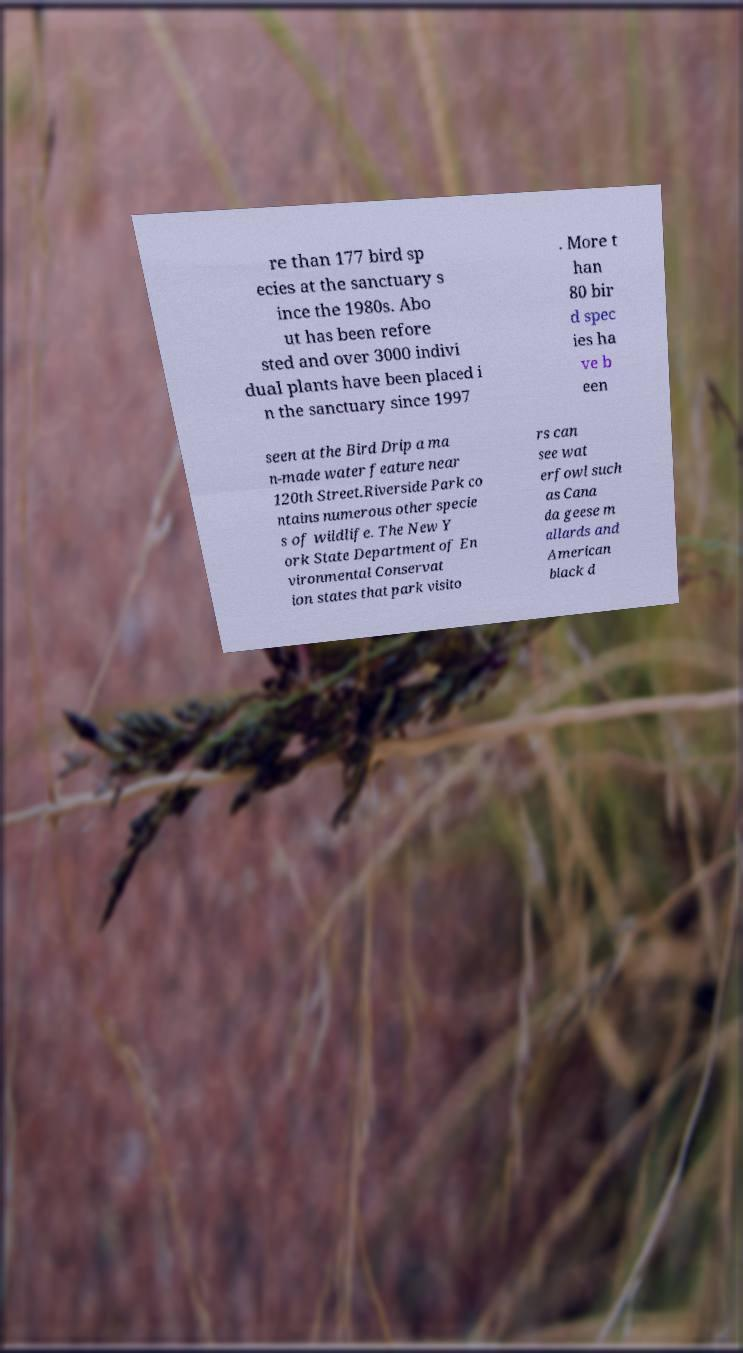Please read and relay the text visible in this image. What does it say? re than 177 bird sp ecies at the sanctuary s ince the 1980s. Abo ut has been refore sted and over 3000 indivi dual plants have been placed i n the sanctuary since 1997 . More t han 80 bir d spec ies ha ve b een seen at the Bird Drip a ma n-made water feature near 120th Street.Riverside Park co ntains numerous other specie s of wildlife. The New Y ork State Department of En vironmental Conservat ion states that park visito rs can see wat erfowl such as Cana da geese m allards and American black d 